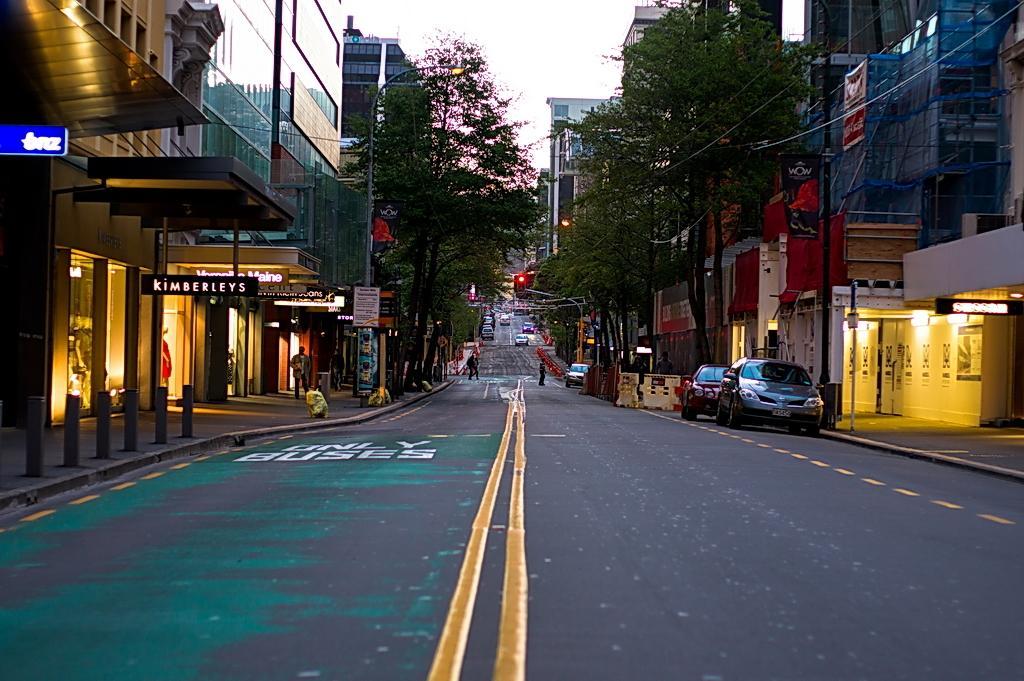How would you summarize this image in a sentence or two? There is a road. On which, there are marks, vehicles and persons walking. On the right side, there are poles on the footpath, there is a person, there are buildings which are having glass windows, there are hoardings and there are trees. On the right side, there is a footpath, there are buildings, there are trees. In the background, there are lights, buildings and there is sky. 